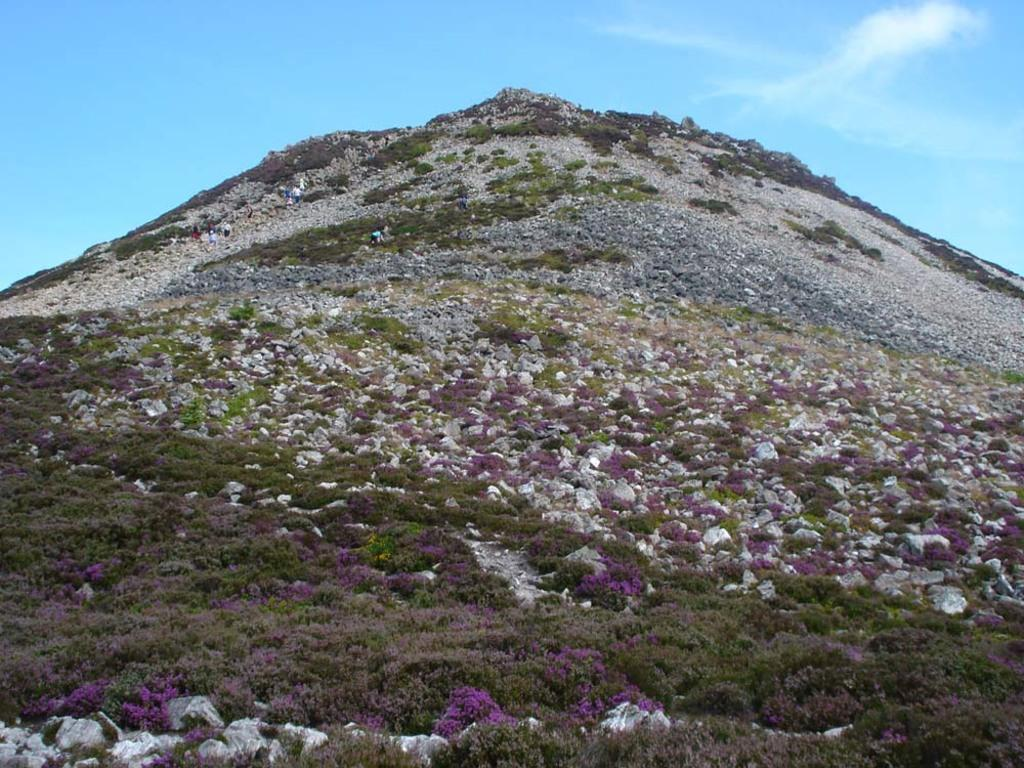What is the main geographical feature in the image? There is a mountain in the image. What type of vegetation can be seen on the mountain? There are trees and flower plants on the mountain. Are there any people present in the image? Yes, there are people standing on the mountain. What can be seen in the background of the image? The sky is visible in the background of the image. What type of design can be seen on the oil spilled on the mountain in the image? There is no oil spilled on the mountain in the image. 